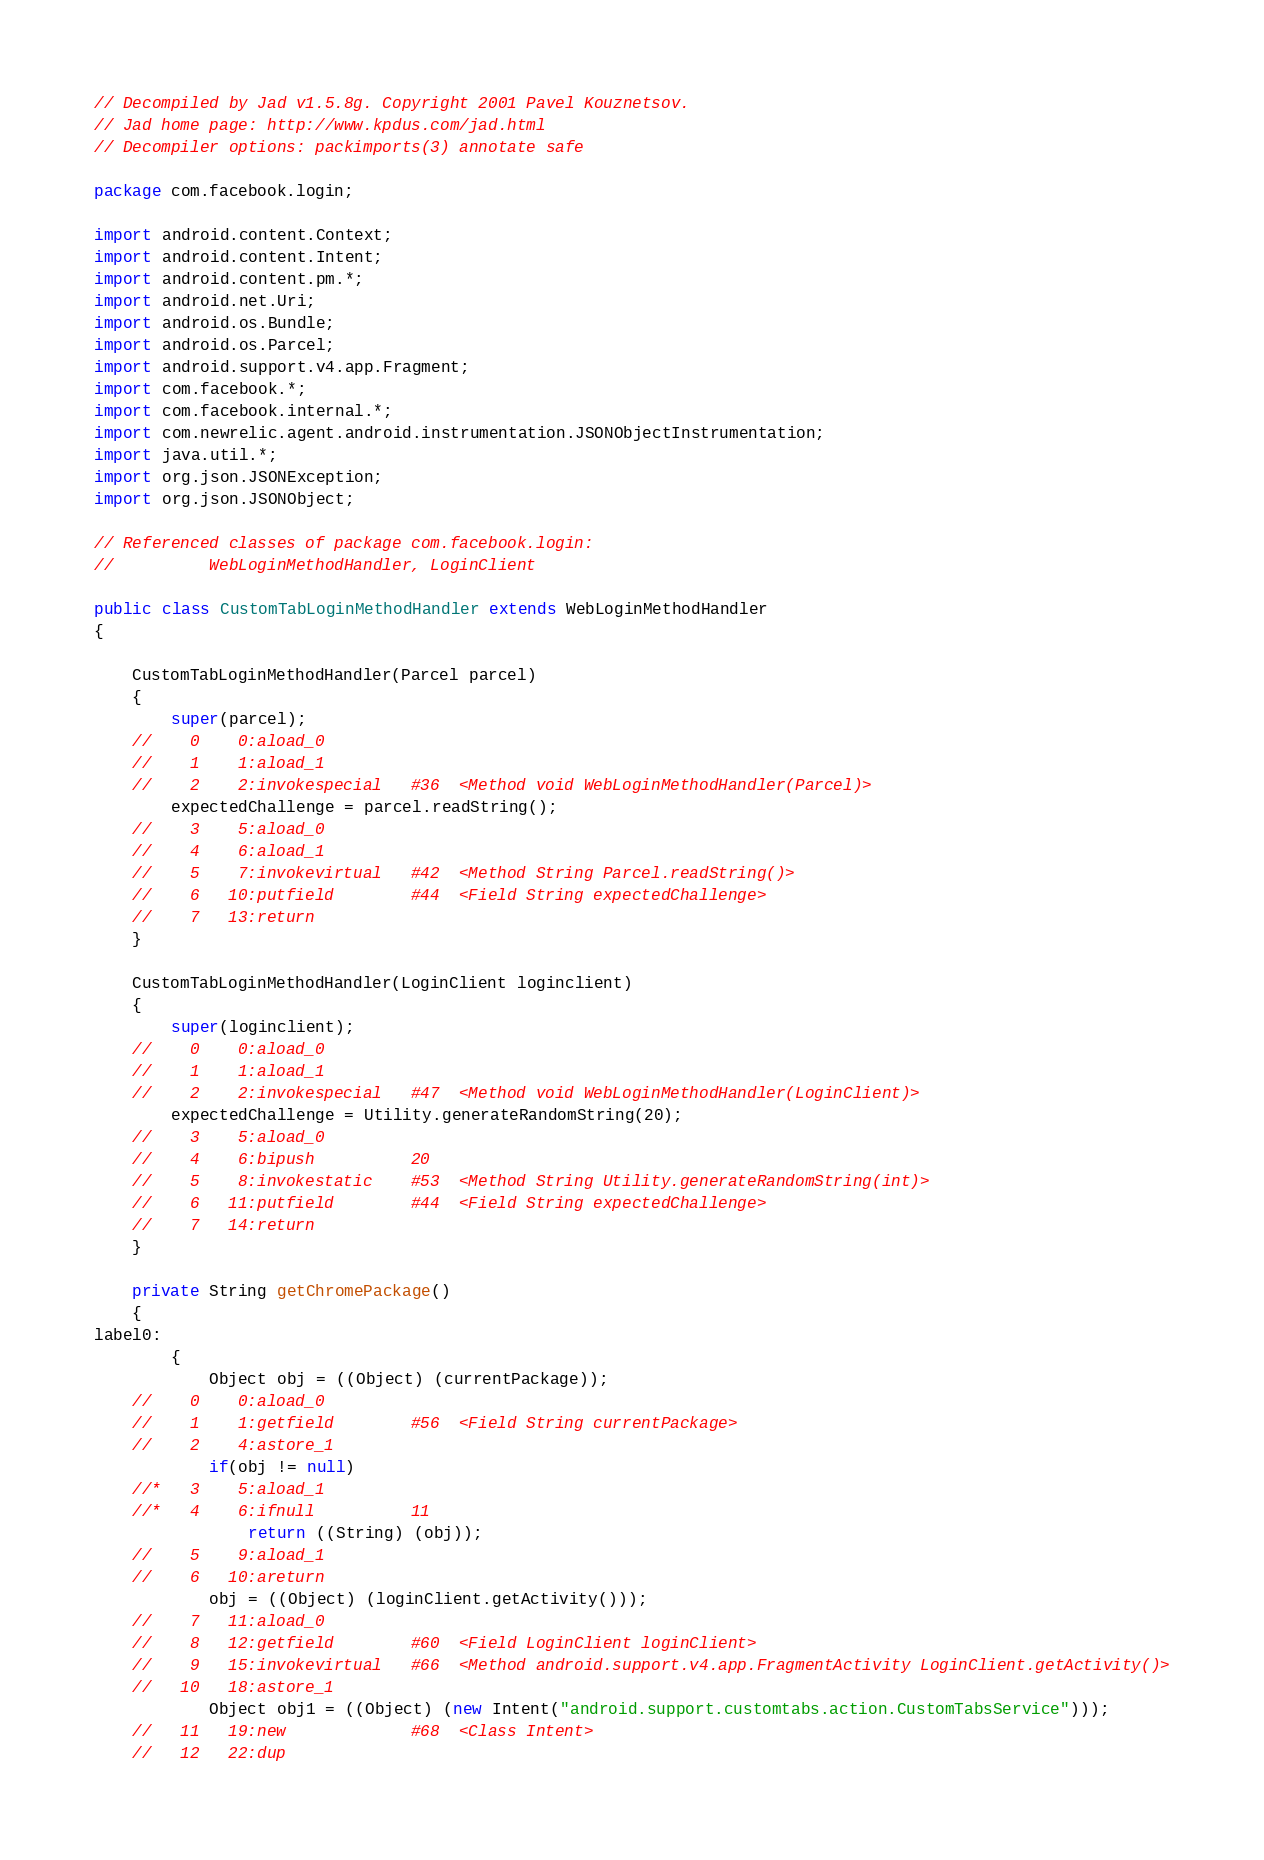Convert code to text. <code><loc_0><loc_0><loc_500><loc_500><_Java_>// Decompiled by Jad v1.5.8g. Copyright 2001 Pavel Kouznetsov.
// Jad home page: http://www.kpdus.com/jad.html
// Decompiler options: packimports(3) annotate safe 

package com.facebook.login;

import android.content.Context;
import android.content.Intent;
import android.content.pm.*;
import android.net.Uri;
import android.os.Bundle;
import android.os.Parcel;
import android.support.v4.app.Fragment;
import com.facebook.*;
import com.facebook.internal.*;
import com.newrelic.agent.android.instrumentation.JSONObjectInstrumentation;
import java.util.*;
import org.json.JSONException;
import org.json.JSONObject;

// Referenced classes of package com.facebook.login:
//			WebLoginMethodHandler, LoginClient

public class CustomTabLoginMethodHandler extends WebLoginMethodHandler
{

	CustomTabLoginMethodHandler(Parcel parcel)
	{
		super(parcel);
	//    0    0:aload_0         
	//    1    1:aload_1         
	//    2    2:invokespecial   #36  <Method void WebLoginMethodHandler(Parcel)>
		expectedChallenge = parcel.readString();
	//    3    5:aload_0         
	//    4    6:aload_1         
	//    5    7:invokevirtual   #42  <Method String Parcel.readString()>
	//    6   10:putfield        #44  <Field String expectedChallenge>
	//    7   13:return          
	}

	CustomTabLoginMethodHandler(LoginClient loginclient)
	{
		super(loginclient);
	//    0    0:aload_0         
	//    1    1:aload_1         
	//    2    2:invokespecial   #47  <Method void WebLoginMethodHandler(LoginClient)>
		expectedChallenge = Utility.generateRandomString(20);
	//    3    5:aload_0         
	//    4    6:bipush          20
	//    5    8:invokestatic    #53  <Method String Utility.generateRandomString(int)>
	//    6   11:putfield        #44  <Field String expectedChallenge>
	//    7   14:return          
	}

	private String getChromePackage()
	{
label0:
		{
			Object obj = ((Object) (currentPackage));
	//    0    0:aload_0         
	//    1    1:getfield        #56  <Field String currentPackage>
	//    2    4:astore_1        
			if(obj != null)
	//*   3    5:aload_1         
	//*   4    6:ifnull          11
				return ((String) (obj));
	//    5    9:aload_1         
	//    6   10:areturn         
			obj = ((Object) (loginClient.getActivity()));
	//    7   11:aload_0         
	//    8   12:getfield        #60  <Field LoginClient loginClient>
	//    9   15:invokevirtual   #66  <Method android.support.v4.app.FragmentActivity LoginClient.getActivity()>
	//   10   18:astore_1        
			Object obj1 = ((Object) (new Intent("android.support.customtabs.action.CustomTabsService")));
	//   11   19:new             #68  <Class Intent>
	//   12   22:dup             </code> 